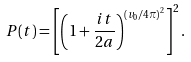<formula> <loc_0><loc_0><loc_500><loc_500>P ( t ) = \left [ \left ( 1 + \frac { i t } { 2 a } \right ) ^ { \left ( v _ { 0 } / 4 \pi \right ) ^ { 2 } } \right ] ^ { 2 } .</formula> 